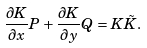<formula> <loc_0><loc_0><loc_500><loc_500>\frac { \partial K } { \partial x } P + \frac { \partial K } { \partial y } Q = K \tilde { K } .</formula> 